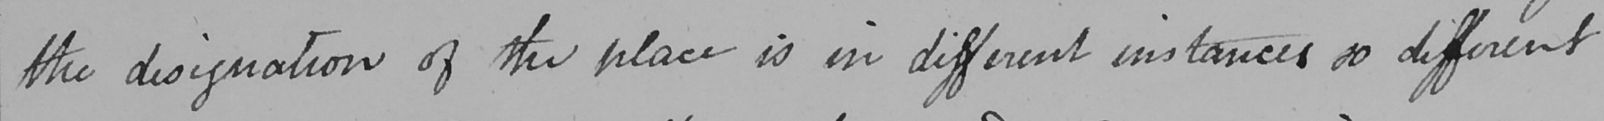What text is written in this handwritten line? the designation of the place is in different instances so different 